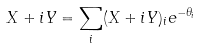Convert formula to latex. <formula><loc_0><loc_0><loc_500><loc_500>X + i Y = \sum _ { i } ( X + i Y ) _ { i } e ^ { - \theta _ { i } }</formula> 